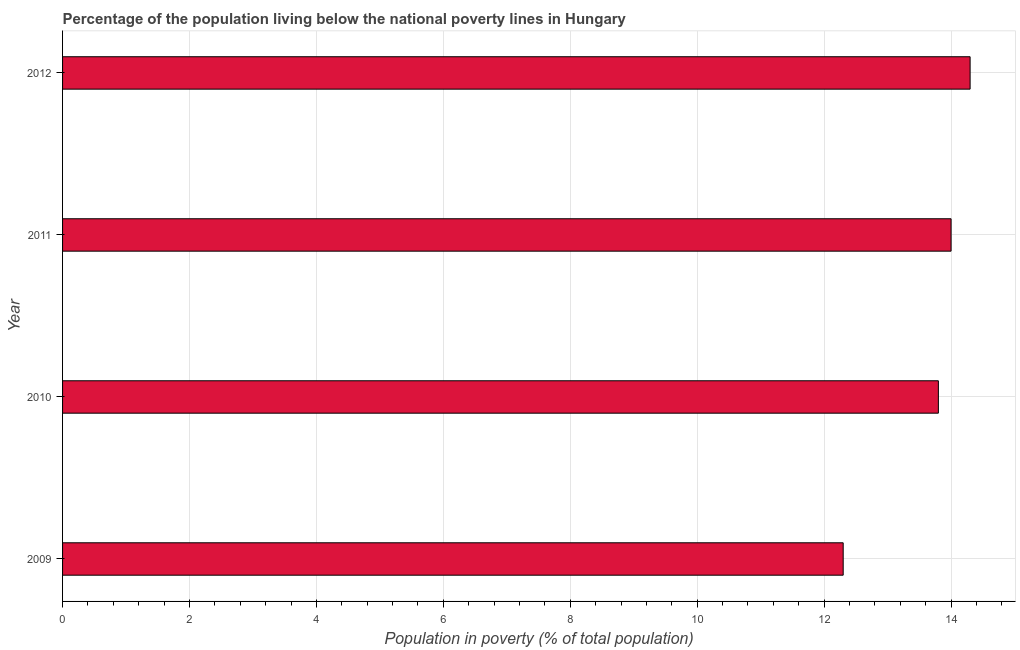Does the graph contain grids?
Give a very brief answer. Yes. What is the title of the graph?
Your response must be concise. Percentage of the population living below the national poverty lines in Hungary. What is the label or title of the X-axis?
Offer a very short reply. Population in poverty (% of total population). What is the label or title of the Y-axis?
Your answer should be very brief. Year. Across all years, what is the maximum percentage of population living below poverty line?
Keep it short and to the point. 14.3. What is the sum of the percentage of population living below poverty line?
Give a very brief answer. 54.4. What is the average percentage of population living below poverty line per year?
Your answer should be compact. 13.6. In how many years, is the percentage of population living below poverty line greater than 14.4 %?
Your response must be concise. 0. Do a majority of the years between 2009 and 2011 (inclusive) have percentage of population living below poverty line greater than 6.8 %?
Offer a very short reply. Yes. What is the ratio of the percentage of population living below poverty line in 2009 to that in 2010?
Keep it short and to the point. 0.89. Is the difference between the percentage of population living below poverty line in 2009 and 2012 greater than the difference between any two years?
Keep it short and to the point. Yes. What is the difference between the highest and the second highest percentage of population living below poverty line?
Offer a very short reply. 0.3. What is the difference between the highest and the lowest percentage of population living below poverty line?
Provide a succinct answer. 2. How many bars are there?
Your answer should be very brief. 4. Are all the bars in the graph horizontal?
Offer a very short reply. Yes. Are the values on the major ticks of X-axis written in scientific E-notation?
Your response must be concise. No. What is the Population in poverty (% of total population) of 2010?
Provide a succinct answer. 13.8. What is the Population in poverty (% of total population) in 2011?
Provide a succinct answer. 14. What is the difference between the Population in poverty (% of total population) in 2009 and 2010?
Provide a short and direct response. -1.5. What is the difference between the Population in poverty (% of total population) in 2009 and 2011?
Offer a terse response. -1.7. What is the difference between the Population in poverty (% of total population) in 2009 and 2012?
Ensure brevity in your answer.  -2. What is the difference between the Population in poverty (% of total population) in 2010 and 2011?
Ensure brevity in your answer.  -0.2. What is the difference between the Population in poverty (% of total population) in 2011 and 2012?
Your answer should be compact. -0.3. What is the ratio of the Population in poverty (% of total population) in 2009 to that in 2010?
Keep it short and to the point. 0.89. What is the ratio of the Population in poverty (% of total population) in 2009 to that in 2011?
Your response must be concise. 0.88. What is the ratio of the Population in poverty (% of total population) in 2009 to that in 2012?
Your answer should be very brief. 0.86. What is the ratio of the Population in poverty (% of total population) in 2011 to that in 2012?
Your answer should be compact. 0.98. 